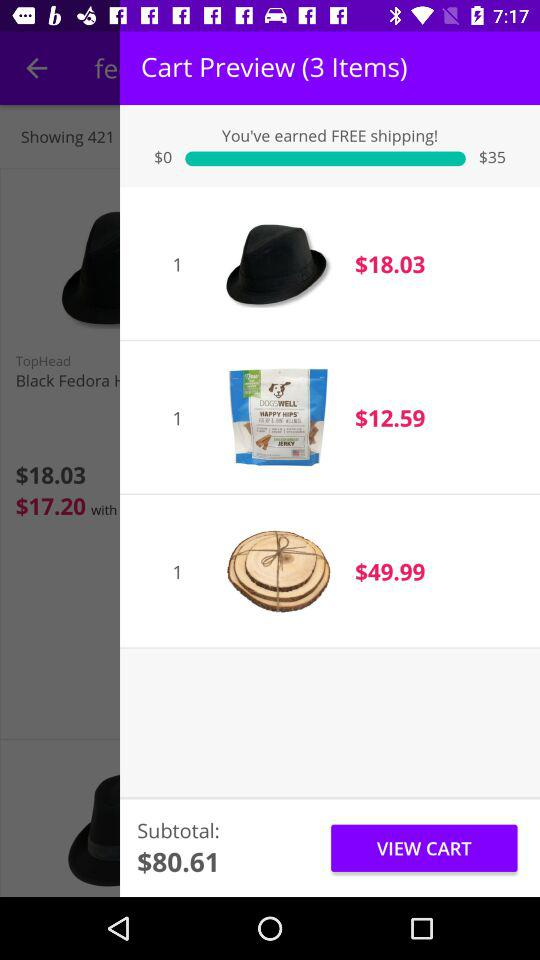How much is the subtotal of the items in the cart?
Answer the question using a single word or phrase. $80.61 